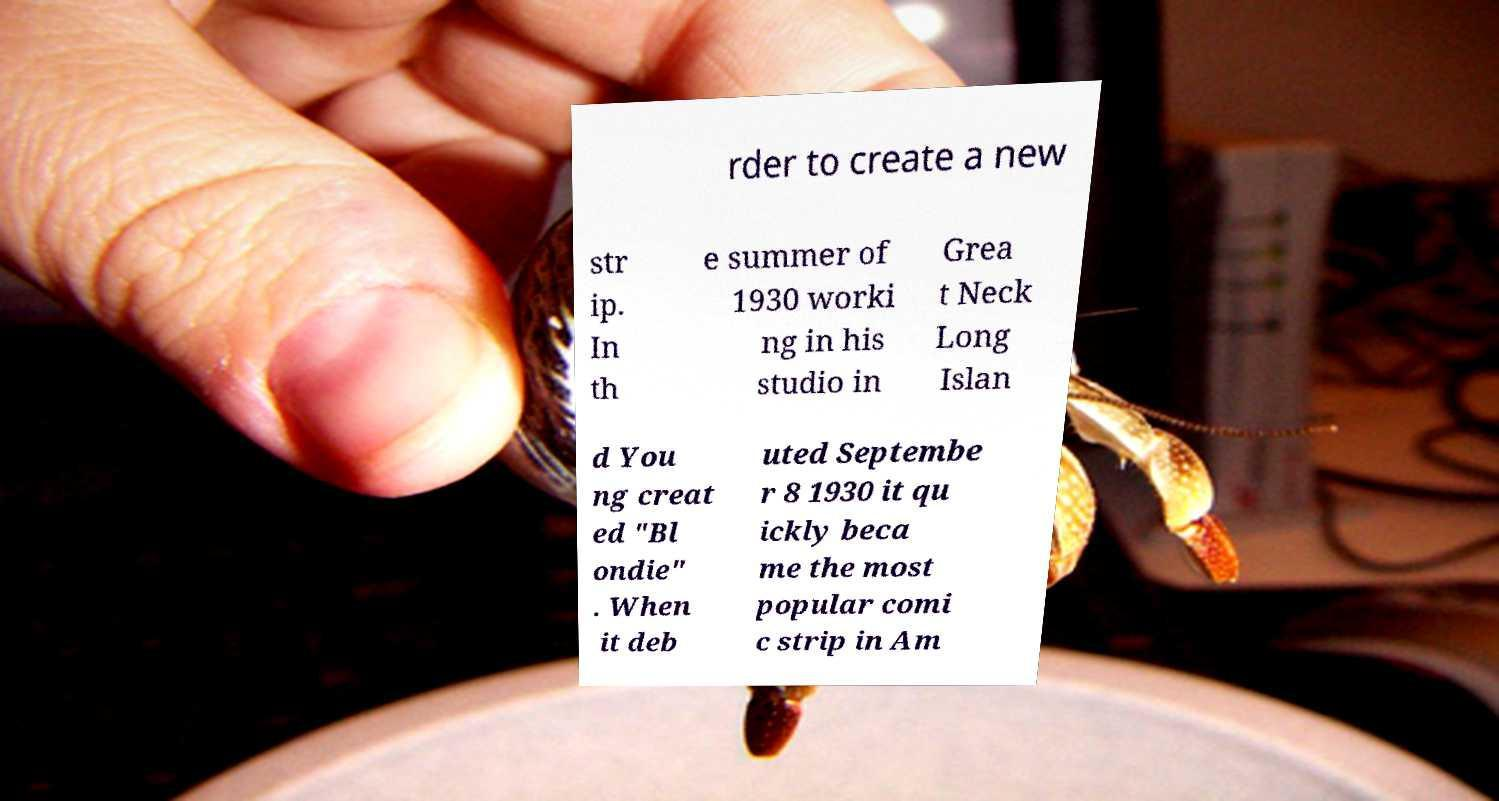What messages or text are displayed in this image? I need them in a readable, typed format. rder to create a new str ip. In th e summer of 1930 worki ng in his studio in Grea t Neck Long Islan d You ng creat ed "Bl ondie" . When it deb uted Septembe r 8 1930 it qu ickly beca me the most popular comi c strip in Am 